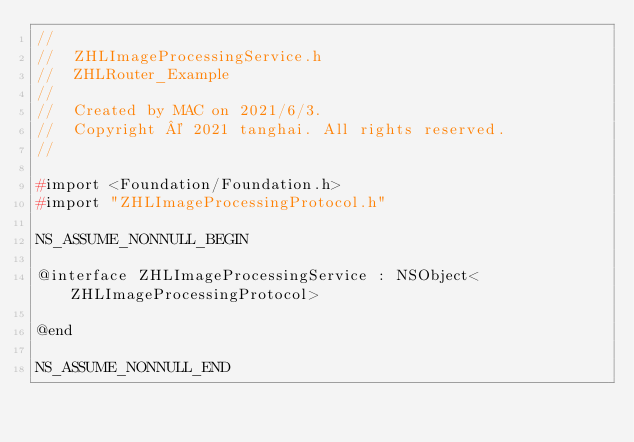Convert code to text. <code><loc_0><loc_0><loc_500><loc_500><_C_>//
//  ZHLImageProcessingService.h
//  ZHLRouter_Example
//
//  Created by MAC on 2021/6/3.
//  Copyright © 2021 tanghai. All rights reserved.
//

#import <Foundation/Foundation.h>
#import "ZHLImageProcessingProtocol.h"

NS_ASSUME_NONNULL_BEGIN

@interface ZHLImageProcessingService : NSObject<ZHLImageProcessingProtocol>

@end

NS_ASSUME_NONNULL_END
</code> 